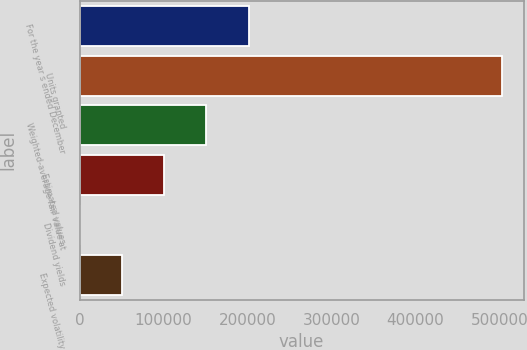<chart> <loc_0><loc_0><loc_500><loc_500><bar_chart><fcel>For the year s ended December<fcel>Units granted<fcel>Weighted-average fair value at<fcel>Estimated values<fcel>Dividend yields<fcel>Expected volatility<nl><fcel>201506<fcel>503761<fcel>151130<fcel>100754<fcel>2.5<fcel>50378.3<nl></chart> 